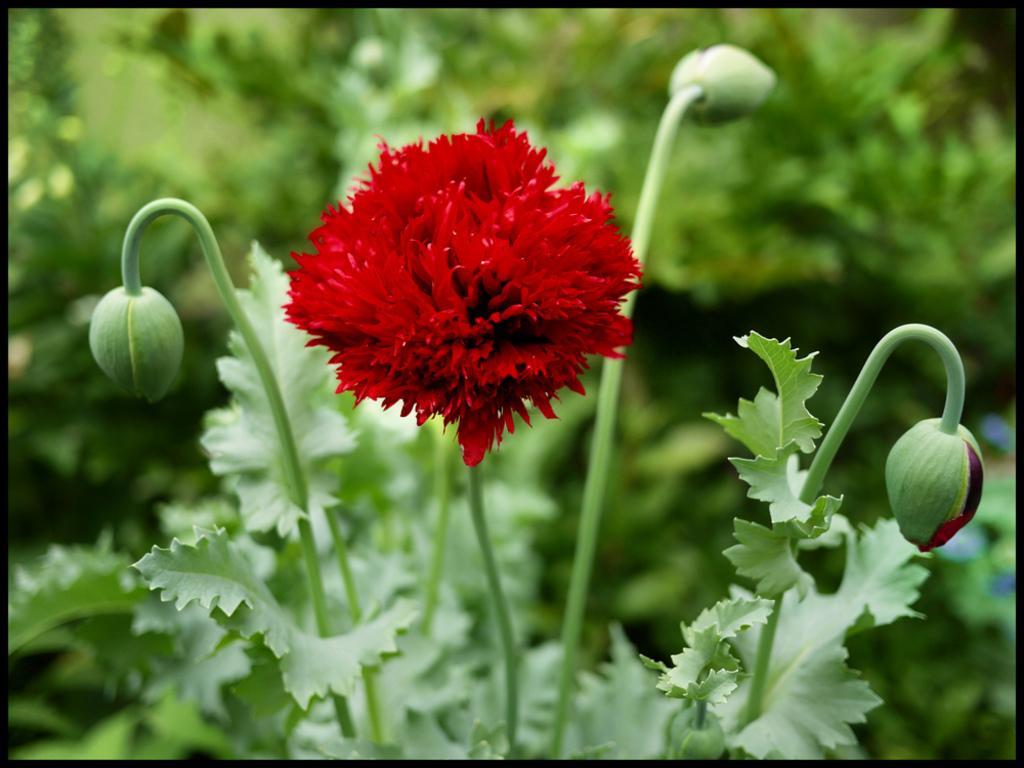Describe this image in one or two sentences. In this image we can see a red color flower and green color leaves. Background of the image is in a blur. 